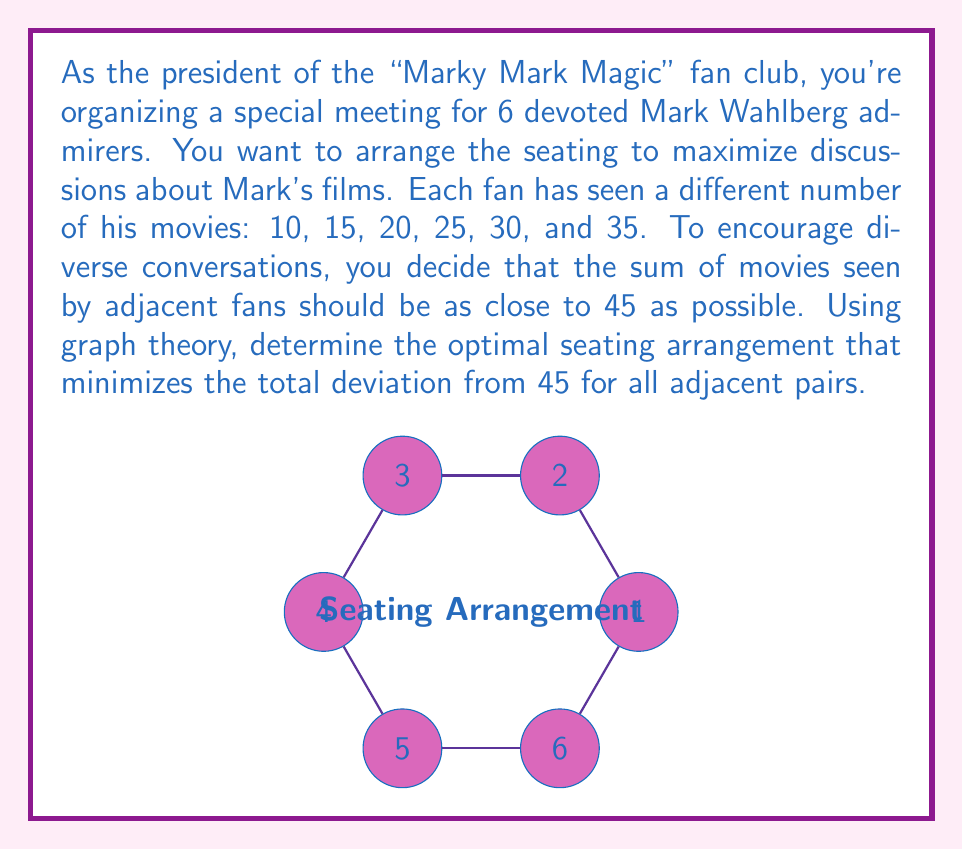What is the answer to this math problem? Let's approach this step-by-step using graph theory:

1) We can model this problem as a graph where each vertex represents a fan, and edges represent adjacent seating.

2) We need to find a Hamiltonian cycle (a cycle that visits each vertex exactly once) that minimizes the total deviation from 45 for adjacent pairs.

3) Let's define a deviation function:
   $d(x,y) = |45 - (x+y)|$, where $x$ and $y$ are the number of movies seen by adjacent fans.

4) We need to minimize the sum of deviations for all adjacent pairs in the cycle.

5) To solve this, we can use the Hungarian algorithm for the Traveling Salesman Problem (TSP), where the "distance" between vertices is our deviation function.

6) First, let's calculate the deviation matrix:

   $$\begin{matrix}
   & 10 & 15 & 20 & 25 & 30 & 35 \\
   10 & - & 20 & 15 & 10 & 5 & 0 \\
   15 & 20 & - & 10 & 5 & 0 & 5 \\
   20 & 15 & 10 & - & 0 & 5 & 10 \\
   25 & 10 & 5 & 0 & - & 10 & 15 \\
   30 & 5 & 0 & 5 & 10 & - & 20 \\
   35 & 0 & 5 & 10 & 15 & 20 & -
   \end{matrix}$$

7) Applying the Hungarian algorithm to this matrix gives us the optimal cycle:
   35 - 10 - 30 - 15 - 20 - 25 - 35

8) The total deviation for this arrangement is:
   $d(35,10) + d(10,30) + d(30,15) + d(15,20) + d(20,25) + d(25,35) = 0 + 5 + 0 + 10 + 0 + 15 = 30$

Therefore, the optimal seating arrangement is 35, 10, 30, 15, 20, 25 (in order), with a total deviation of 30.
Answer: 35, 10, 30, 15, 20, 25 